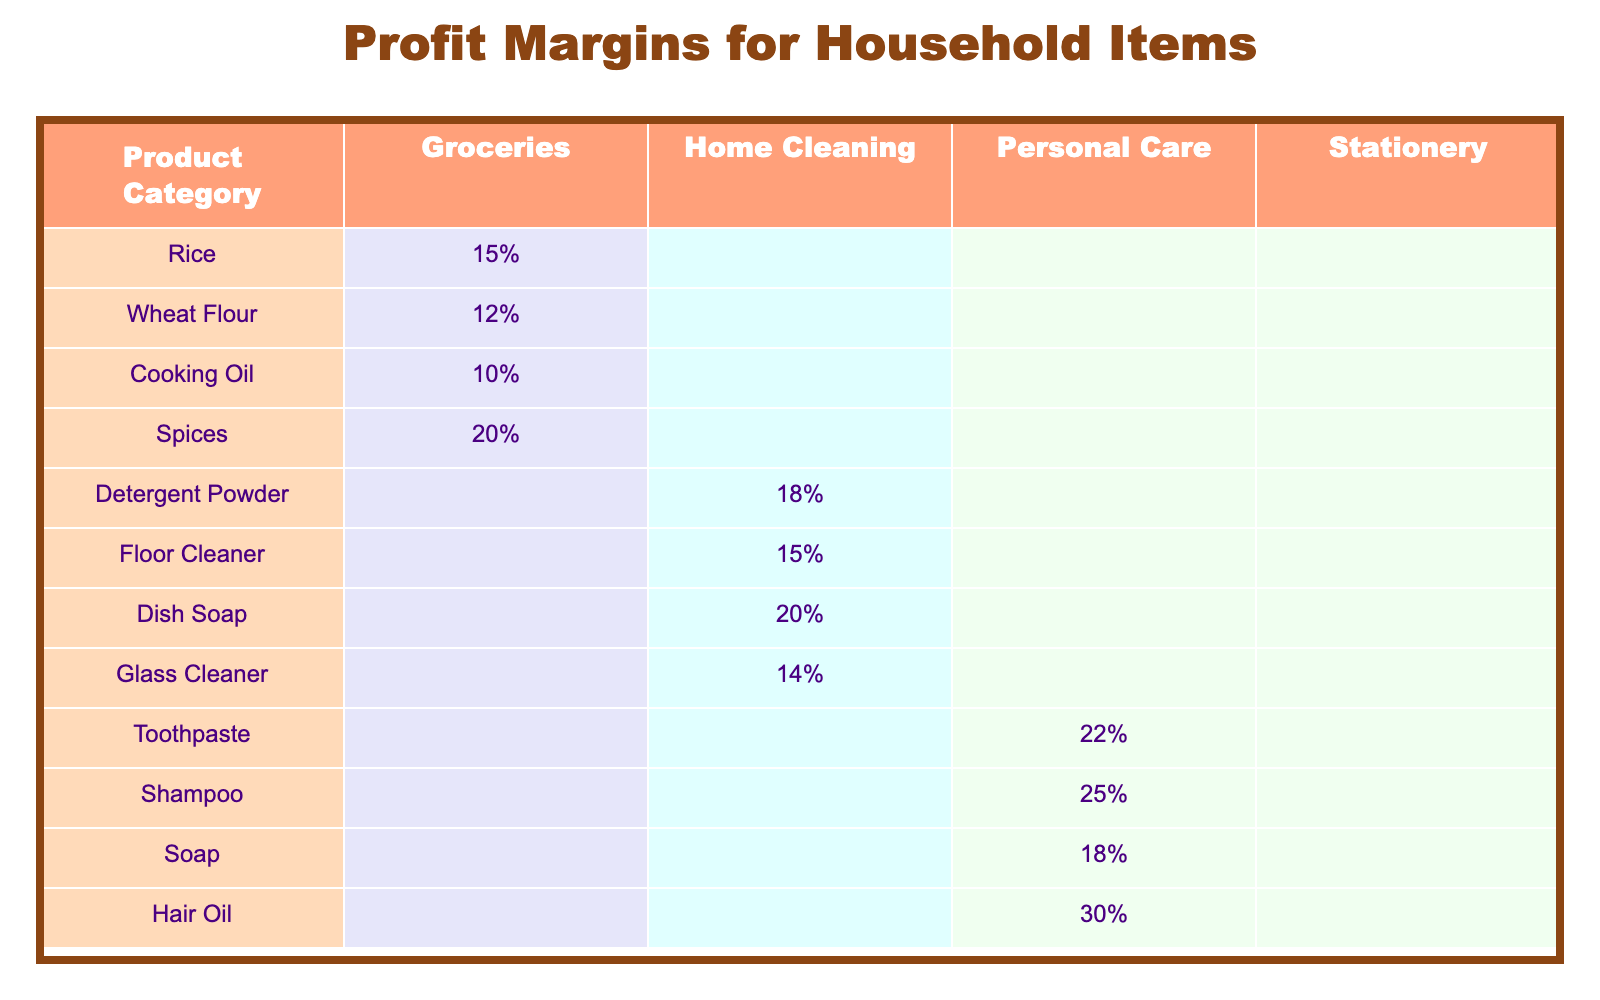What is the profit margin for Rice? The table lists the profit margin for Rice under the Groceries category as 15%.
Answer: 15% What product has the highest profit margin in Personal Care? By examining the Personal Care column, Hair Oil has the highest profit margin listed at 30%.
Answer: Hair Oil Which category has the least profit margin for any item? The lowest profit margin discovered in the table is for Cooking Oil in the Groceries category, which is listed at 10%.
Answer: Groceries What is the average profit margin for Home Cleaning products? The profit margins for Home Cleaning products are Detergent Powder (18%), Floor Cleaner (15%), Dish Soap (20%), and Glass Cleaner (14%). The sum of these is 67%, and there are 4 products. Therefore, the average is 67% / 4 = 16.75%.
Answer: 16.75% Is the profit margin for Shampoo higher than that for Soap? Shampoo has a profit margin of 25%, while Soap has a profit margin of 18%. Since 25% is greater than 18%, Shampoo has a higher profit margin.
Answer: Yes What is the difference in profit margins between Spices and Toothpaste? The profit margin for Spices is 20%, and for Toothpaste, it is 22%. Calculating the difference: 22% - 20% = 2%.
Answer: 2% How many product categories have a profit margin of 20% or more? In the table, we have Spices (20%), Dish Soap (20%), Toothpaste (22%), Shampoo (25%), and Hair Oil (30%). This totals to 5 products that meet the criteria.
Answer: 5 Which category do most high-margin products belong to? Reviewing the profit margins, Personal Care has the highest margins (Shampoo 25%, Toothpaste 22%, Hair Oil 30%) compared to Groceries (with a maximum of 20%) and Home Cleaning (with a maximum of 20%). Hence, it can be concluded that Personal Care features the majority of high-margin products.
Answer: Personal Care Is there a product in the Stationery category listed in the table? Upon reviewing the table, there are no profit margins recorded for any products in the Stationery category, indicating it is empty.
Answer: No What products have a profit margin lower than 15%? The only product that has a profit margin lower than 15% is Cooking Oil with a margin of 10%.
Answer: Cooking Oil 